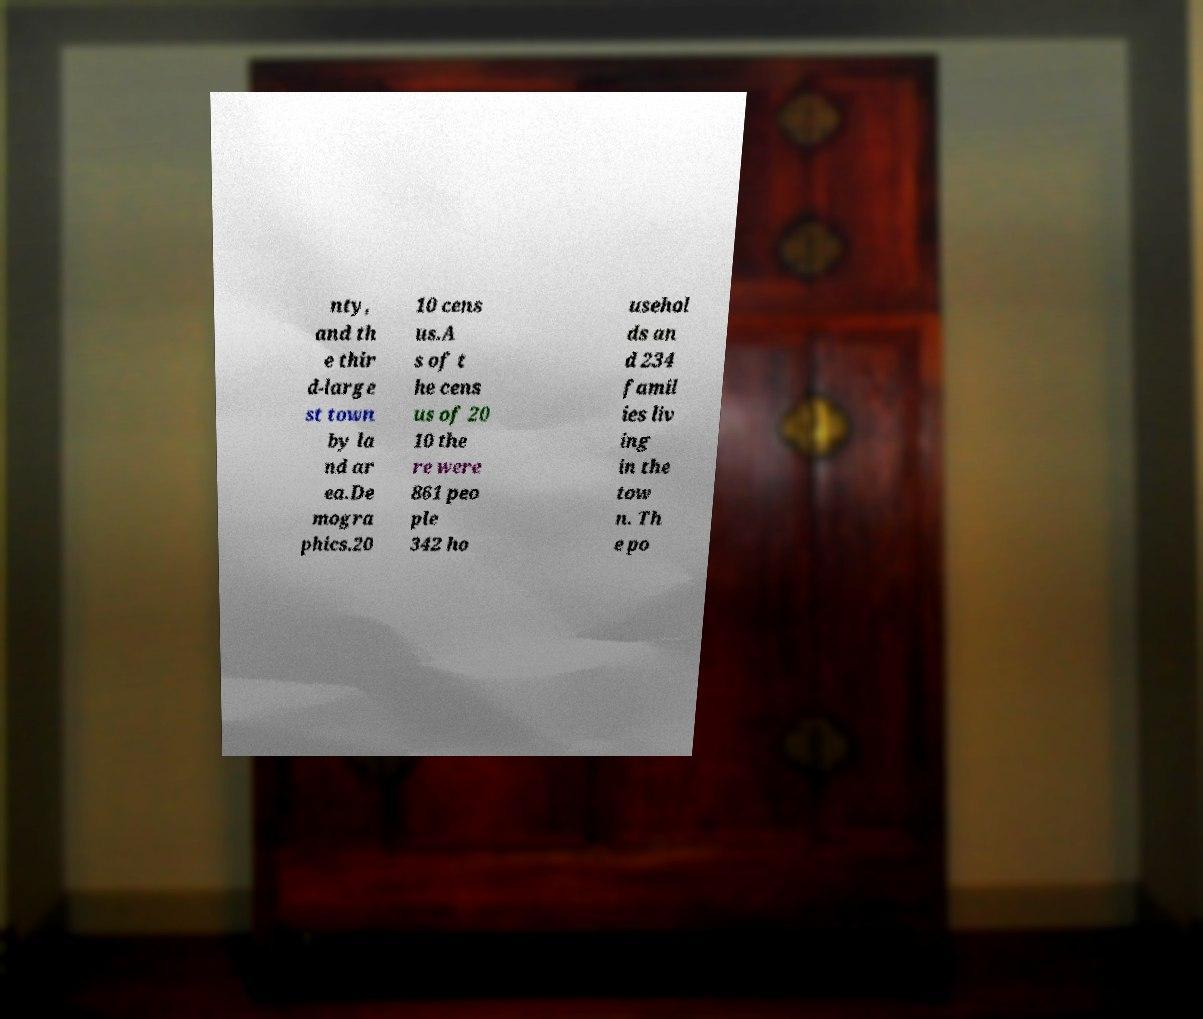I need the written content from this picture converted into text. Can you do that? nty, and th e thir d-large st town by la nd ar ea.De mogra phics.20 10 cens us.A s of t he cens us of 20 10 the re were 861 peo ple 342 ho usehol ds an d 234 famil ies liv ing in the tow n. Th e po 